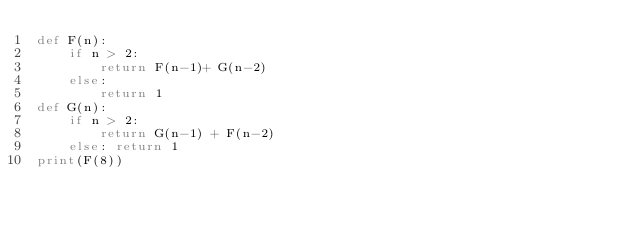<code> <loc_0><loc_0><loc_500><loc_500><_Python_>def F(n):
    if n > 2:
        return F(n-1)+ G(n-2)
    else:
        return 1
def G(n):
    if n > 2:
        return G(n-1) + F(n-2)
    else: return 1
print(F(8))</code> 